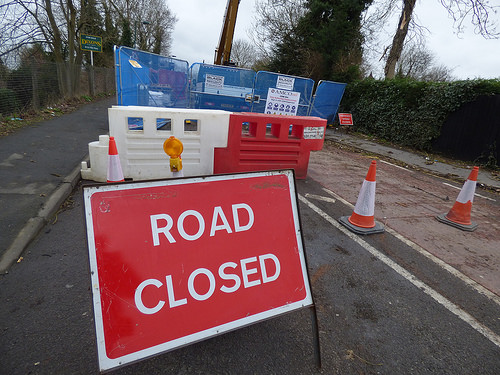<image>
Is the sign behind the cone? No. The sign is not behind the cone. From this viewpoint, the sign appears to be positioned elsewhere in the scene. Where is the fence in relation to the sign? Is it above the sign? No. The fence is not positioned above the sign. The vertical arrangement shows a different relationship. 